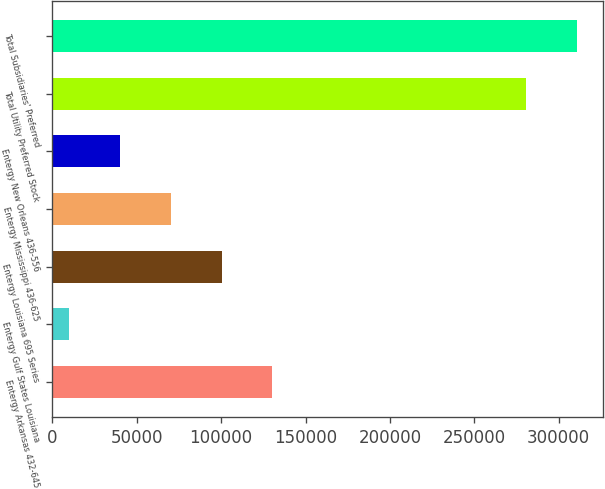<chart> <loc_0><loc_0><loc_500><loc_500><bar_chart><fcel>Entergy Arkansas 432-645<fcel>Entergy Gulf States Louisiana<fcel>Entergy Louisiana 695 Series<fcel>Entergy Mississippi 436-625<fcel>Entergy New Orleans 436-556<fcel>Total Utility Preferred Stock<fcel>Total Subsidiaries' Preferred<nl><fcel>130295<fcel>10000<fcel>100221<fcel>70147.6<fcel>40073.8<fcel>280511<fcel>310738<nl></chart> 